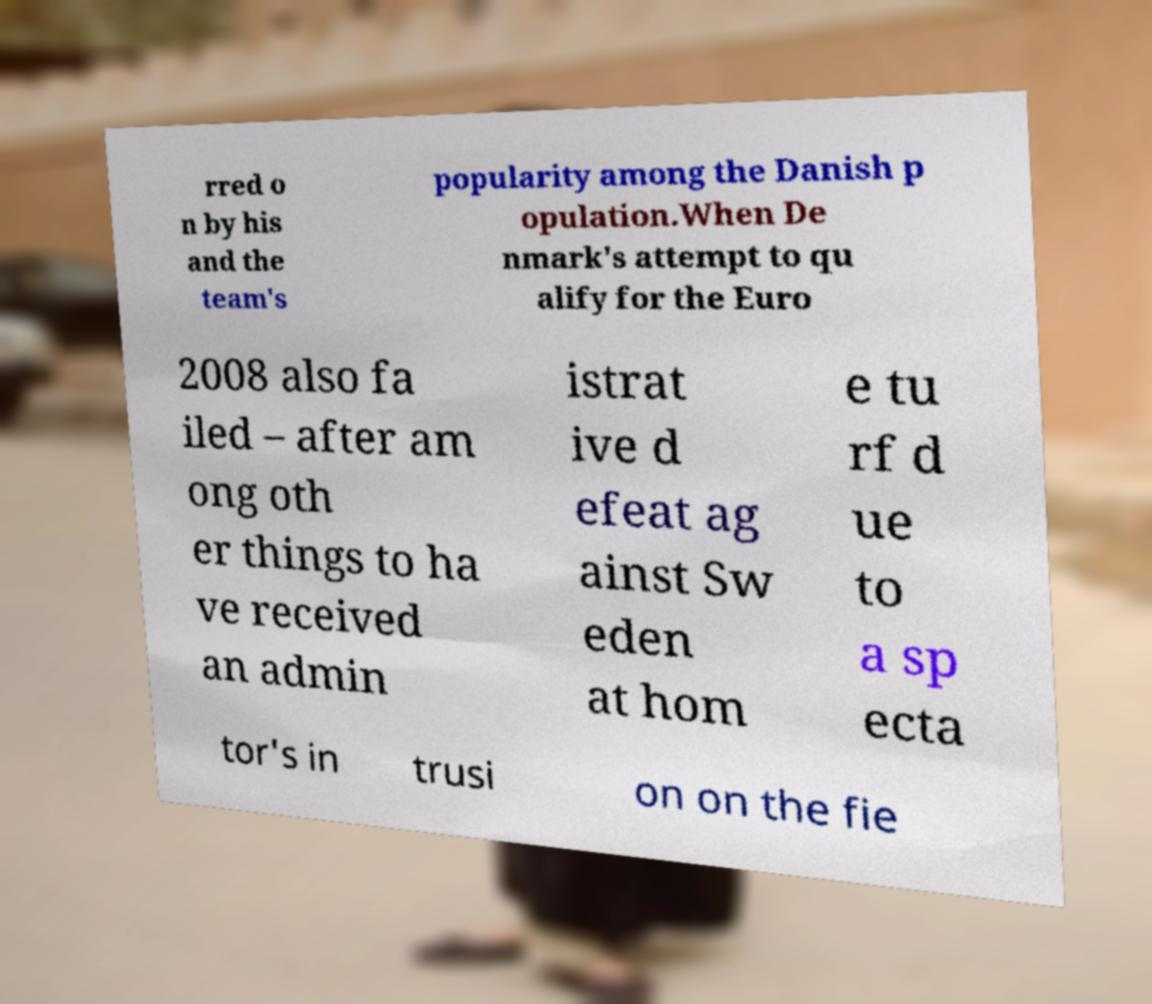Please identify and transcribe the text found in this image. rred o n by his and the team's popularity among the Danish p opulation.When De nmark's attempt to qu alify for the Euro 2008 also fa iled – after am ong oth er things to ha ve received an admin istrat ive d efeat ag ainst Sw eden at hom e tu rf d ue to a sp ecta tor's in trusi on on the fie 